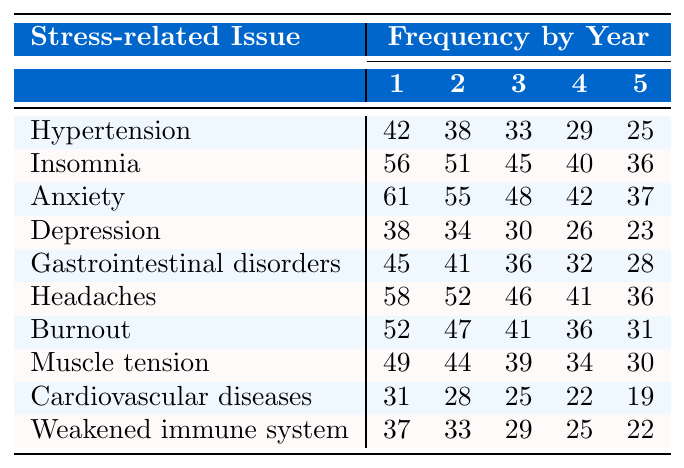What is the frequency of hypertension in the first year? The table shows the frequency of stress-related issues. For hypertension, the value in the first year is 42.
Answer: 42 What was the lowest frequency of anxiety over the five years? By examining the column for anxiety in each year, the lowest frequency occurs in the fifth year, which is 37.
Answer: 37 What stress-related issue had the highest frequency in year 2? Looking at year 2, insomnia shows the highest frequency with a value of 51.
Answer: 51 How many stress-related issues have a frequency of 30 or less in the fifth year? In the fifth year, the frequency of each issue is 25 for hypertension, 36 for insomnia, 37 for anxiety, 23 for depression, 28 for gastrointestinal disorders, 36 for headaches, 31 for burnout, 30 for muscle tension, 19 for cardiovascular diseases, and 22 for weakened immune system. Only depression (23) and cardiovascular diseases (19) are 30 or less, giving us a total of 2.
Answer: 2 What is the average frequency of gastrointestinal disorders over the five years? Sum the frequencies of gastrointestinal disorders: 45 + 41 + 36 + 32 + 28 = 182. Then divide by the number of years (5) to get the average 182 / 5 = 36.4.
Answer: 36.4 Is there a decreasing trend for headaches from the first year to the fifth year? Checking the headache frequencies: 58 (year 1), 52 (year 2), 46 (year 3), 41 (year 4), and 36 (year 5). Each subsequent year shows a decrease, confirming a decreasing trend.
Answer: Yes How many total stress-related issues show a frequency of 40 or more in year 4? In year 4, check each frequency: Hypertension (29), Insomnia (40), Anxiety (42), Depression (26), Gastrointestinal disorders (32), Headaches (41), Burnout (36), Muscle tension (34), Cardiovascular diseases (22), Weakened immune system (25). The issues that show 40 or more are insomnia (40), anxiety (42), headaches (41), and burnout (36), totaling 4.
Answer: 4 What is the difference in frequency of burnout between years 1 and 5? Year 1 burnout frequency is 52 and year 5 is 31. The difference is calculated as 52 - 31 = 21.
Answer: 21 Do muscle tension and weakened immune system frequencies decrease consistently each year? Muscle tension frequencies are 49, 44, 39, 34, and 30, which shows consistent decline. Weakened immune system frequencies are 37, 33, 29, 25, and 22, which also shows consistent decline. Therefore, both issues decrease consistently each year.
Answer: Yes In which year do anxiety frequencies drop below 50 for the first time? Looking at the anxiety frequencies across the years: 61 (year 1), 55 (year 2), 48 (year 3), 42 (year 4), and 37 (year 5), it first drops below 50 in year 3.
Answer: Year 3 